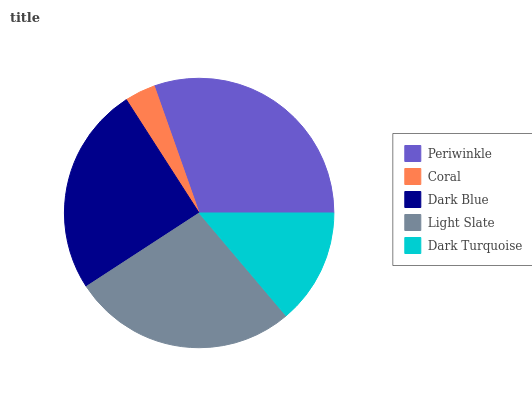Is Coral the minimum?
Answer yes or no. Yes. Is Periwinkle the maximum?
Answer yes or no. Yes. Is Dark Blue the minimum?
Answer yes or no. No. Is Dark Blue the maximum?
Answer yes or no. No. Is Dark Blue greater than Coral?
Answer yes or no. Yes. Is Coral less than Dark Blue?
Answer yes or no. Yes. Is Coral greater than Dark Blue?
Answer yes or no. No. Is Dark Blue less than Coral?
Answer yes or no. No. Is Dark Blue the high median?
Answer yes or no. Yes. Is Dark Blue the low median?
Answer yes or no. Yes. Is Dark Turquoise the high median?
Answer yes or no. No. Is Coral the low median?
Answer yes or no. No. 